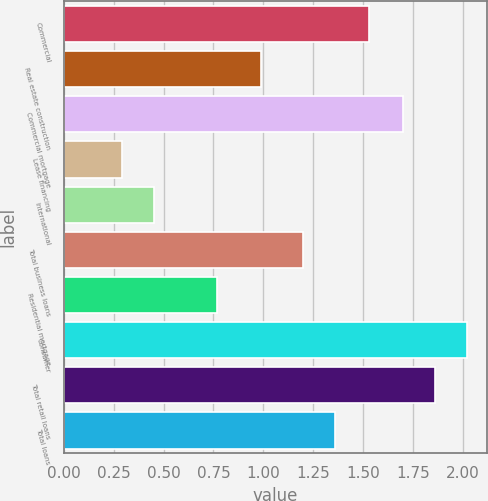Convert chart to OTSL. <chart><loc_0><loc_0><loc_500><loc_500><bar_chart><fcel>Commercial<fcel>Real estate construction<fcel>Commercial mortgage<fcel>Lease financing<fcel>International<fcel>Total business loans<fcel>Residential mortgage<fcel>Consumer<fcel>Total retail loans<fcel>Total loans<nl><fcel>1.53<fcel>0.99<fcel>1.7<fcel>0.29<fcel>0.45<fcel>1.2<fcel>0.77<fcel>2.02<fcel>1.86<fcel>1.36<nl></chart> 